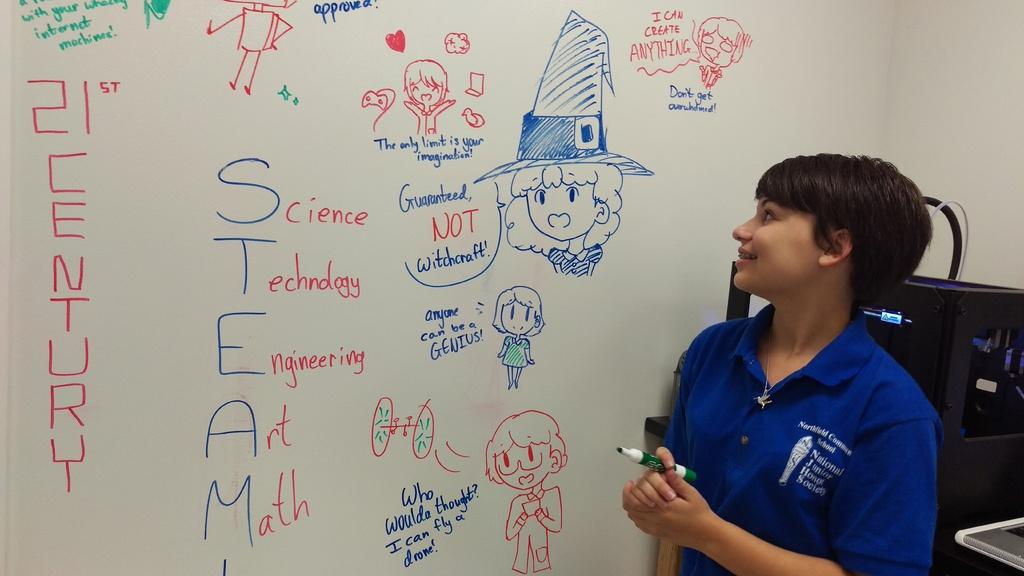What century is mentioned?
Offer a very short reply. 21st. What word is written in blue vertically?
Keep it short and to the point. Steam. 